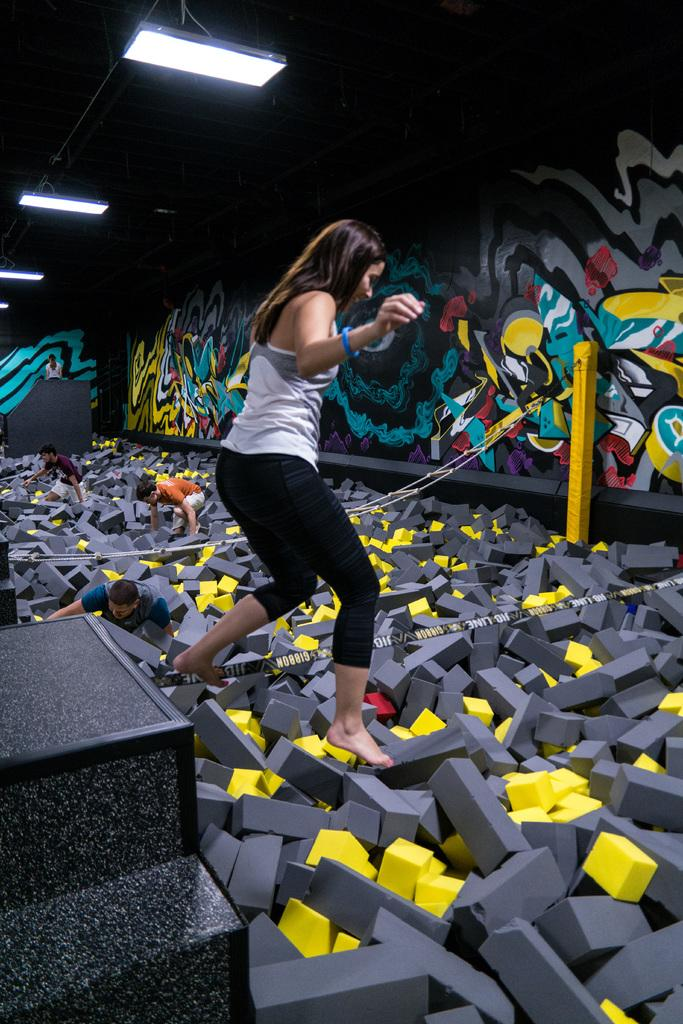What objects can be seen in the image that are made of sponge? There are sponge pieces in the image. What architectural feature is present in the image? There are stairs in the image. Who is present in the image? There is a woman and children in the image. What is the color of the pole in the image? The pole in the image is yellow. What type of structure is visible in the image? There is a wall in the image. Where are the lights located in the image? The lights are in the top left of the image. Can you see a robin perched on the yellow pole in the image? There is no robin present in the image; it only features sponge pieces, stairs, a woman, children, a yellow pole, a wall, and lights. What example of a sheet can be seen in the image? There is no sheet present in the image. 